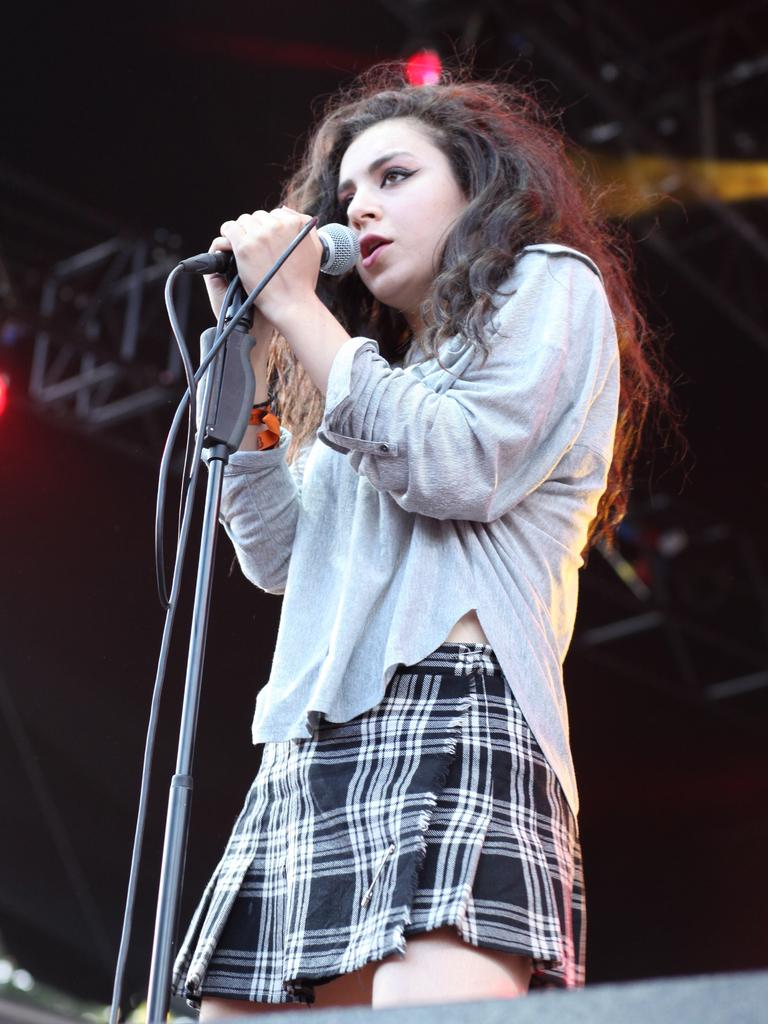Who is the main subject in the image? There is a girl in the image. What is the girl doing in the image? The girl is standing and singing. What object is the girl holding in the image? The girl is holding a microphone in the image. Is the girl wearing a mask while singing in the image? There is no mention of a mask in the image, so it cannot be determined whether the girl is wearing one or not. 